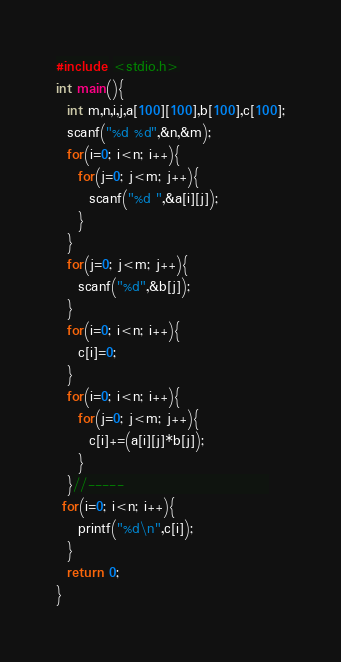Convert code to text. <code><loc_0><loc_0><loc_500><loc_500><_C_>
#include <stdio.h>
int main(){
  int m,n,i,j,a[100][100],b[100],c[100];
  scanf("%d %d",&n,&m);
  for(i=0; i<n; i++){
    for(j=0; j<m; j++){
      scanf("%d ",&a[i][j]);
    }   
  }
  for(j=0; j<m; j++){
    scanf("%d",&b[j]);
  }
  for(i=0; i<n; i++){
    c[i]=0;
  }
  for(i=0; i<n; i++){
    for(j=0; j<m; j++){
      c[i]+=(a[i][j]*b[j]);
    }
  }//-----                          
 for(i=0; i<n; i++){
    printf("%d\n",c[i]);
  }
  return 0;
}
</code> 